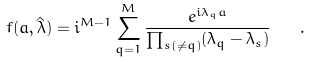Convert formula to latex. <formula><loc_0><loc_0><loc_500><loc_500>f ( a , \hat { \lambda } ) = i ^ { M - 1 } \sum _ { q = 1 } ^ { M } \frac { e ^ { i \lambda _ { q } a } } { \prod _ { s ( \ne q ) } ( \lambda _ { q } - \lambda _ { s } ) } \quad .</formula> 